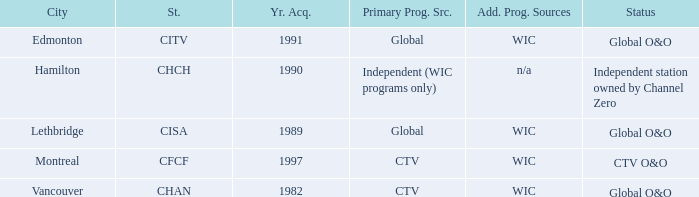Where is citv located Edmonton. 